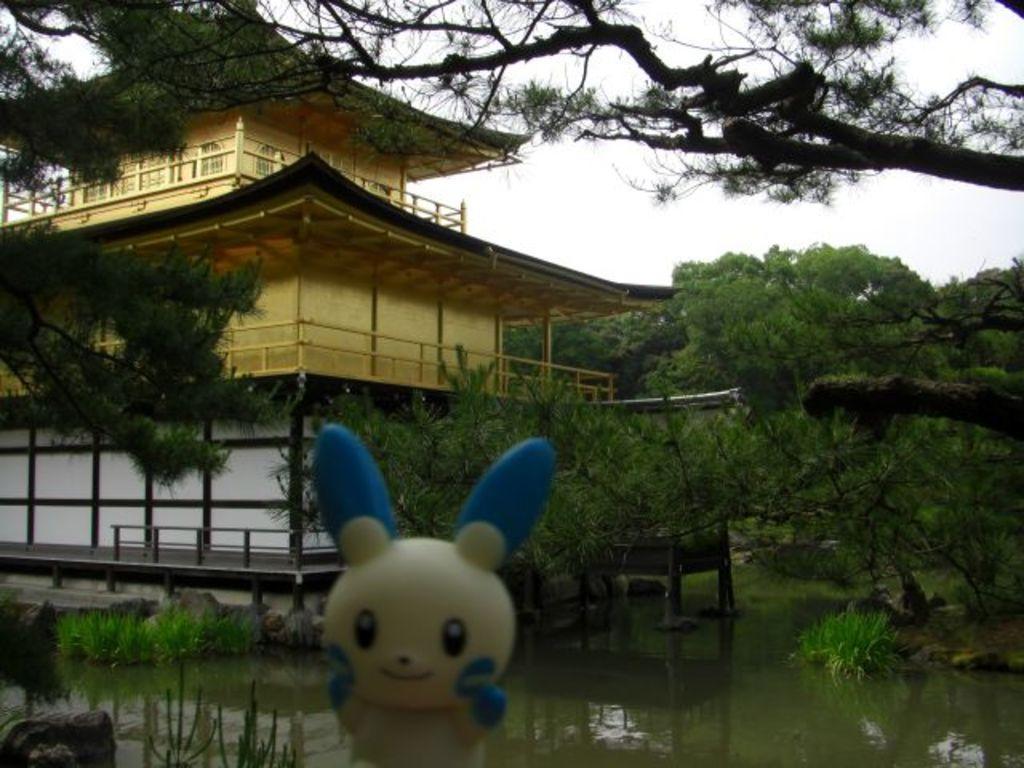In one or two sentences, can you explain what this image depicts? In this picture we can see a toy, water, rocks, plants, building, trees and in the background we can see the sky. 